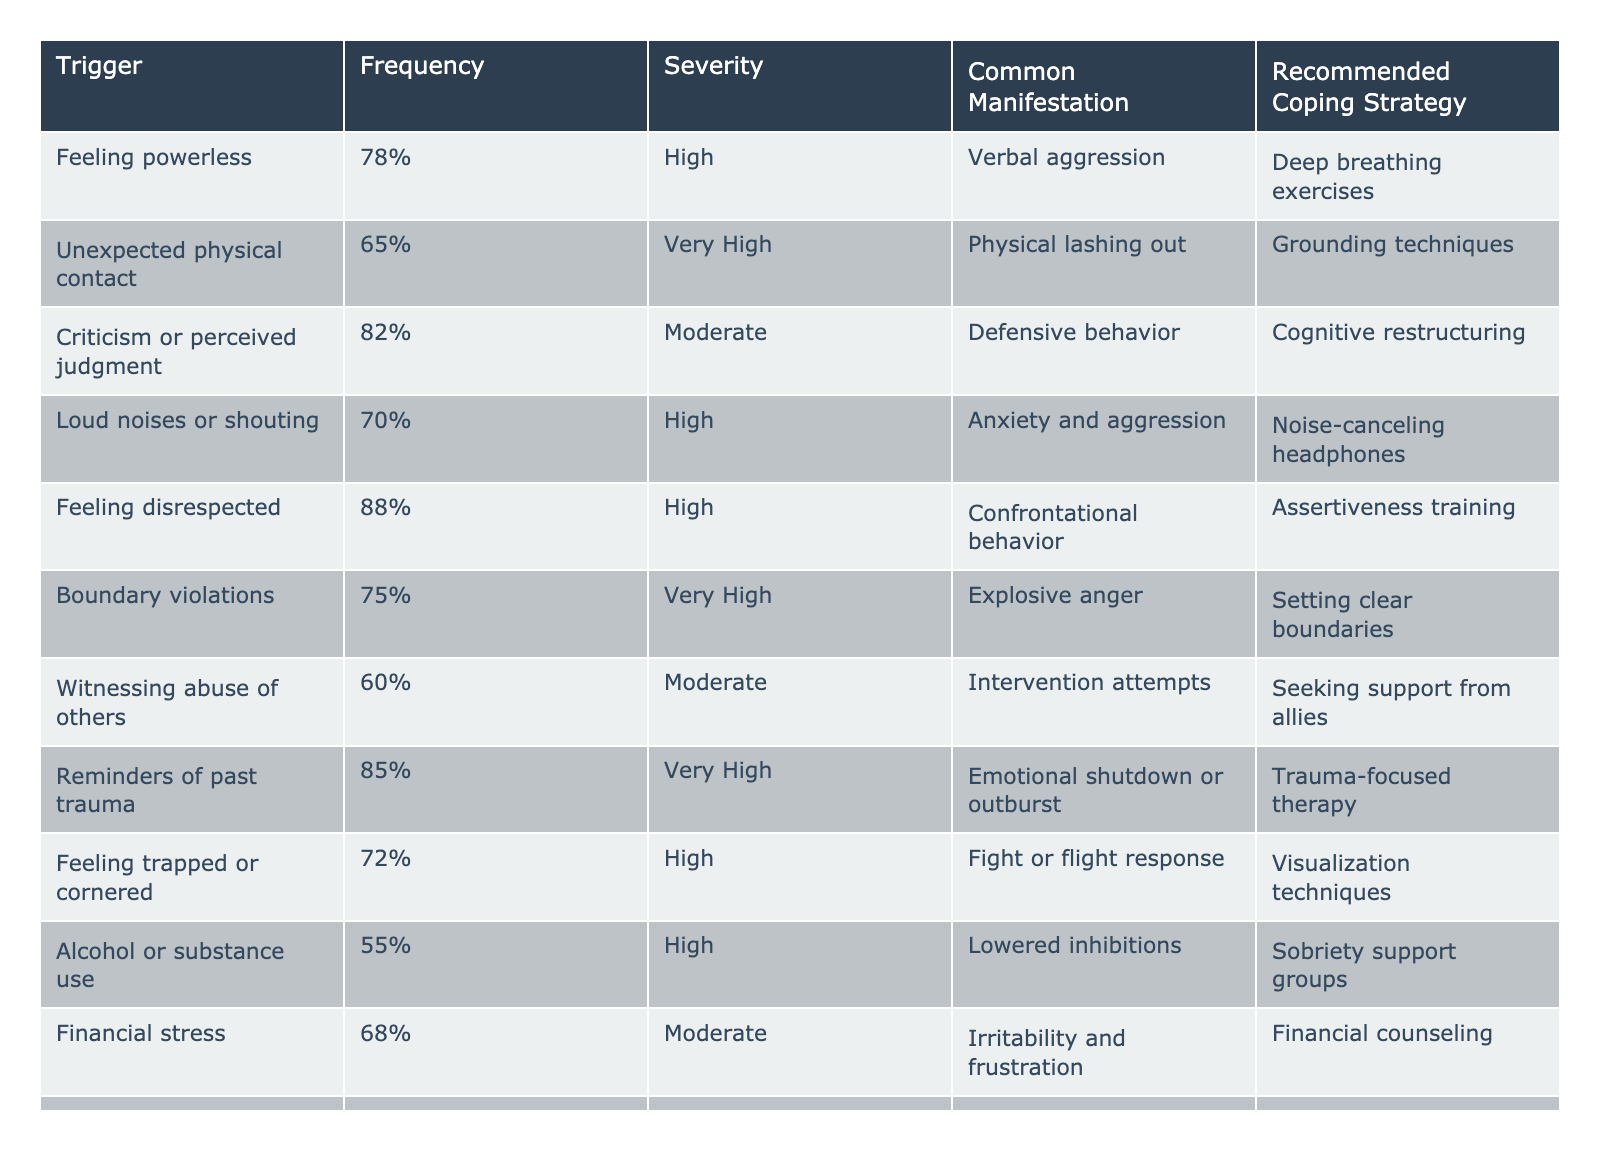What is the most frequently reported trigger for anger outbursts? The trigger with the highest frequency for anger outbursts is "Feeling disrespected," which has a frequency of 88%.
Answer: 88% Which trigger has a very high severity rating? The triggers with a very high severity rating are "Unexpected physical contact," "Reminders of past trauma," "Boundary violations," and "Perceived threats to loved ones."
Answer: 4 triggers What is the common manifestation for the trigger "Criticism or perceived judgment"? The common manifestation for "Criticism or perceived judgment" is defensive behavior.
Answer: Defensive behavior What percentage of people reported feeling powerless as a trigger for anger outbursts? The percentage of people who reported feeling powerless as a trigger is 78%.
Answer: 78% How many triggers have a frequency of 70% or higher? The triggers with a frequency of 70% or higher are "Feeling disrespected," "Reminders of past trauma," "Criticism or perceived judgment," "Feeling powerless," "Boundary violations," "Unexpected physical contact," and "Loud noises or shouting," making a total of 7 triggers.
Answer: 7 Is "Financial stress" a common trigger for anger outbursts? Yes, "Financial stress" is listed as a trigger with a frequency of 68%, which indicates it is commonly reported.
Answer: Yes Which coping strategy is recommended for the trigger "Feeling trapped or cornered"? The recommended coping strategy for "Feeling trapped or cornered" is visualization techniques.
Answer: Visualization techniques Calculate the average severity of triggers that result in "Physical lashing out" and "Explosive anger." The severity ratings for these triggers are "Very High" (Physical lashing out) and "Very High" (Explosive anger). Both can be counted as equivalent to a numerical value of 4. Hence, the average severity = (4 + 4) / 2 = 4.
Answer: 4 What are the two coping strategies recommended for triggers related to physical aggression? The recommended coping strategies for triggers related to physical aggression are grounding techniques for unexpected physical contact and assertiveness training for feeling disrespected.
Answer: Grounding techniques and assertiveness training Which trigger has the lowest frequency, and what is its value? The trigger with the lowest frequency is "Alcohol or substance use," which has a frequency of 55%.
Answer: 55% 